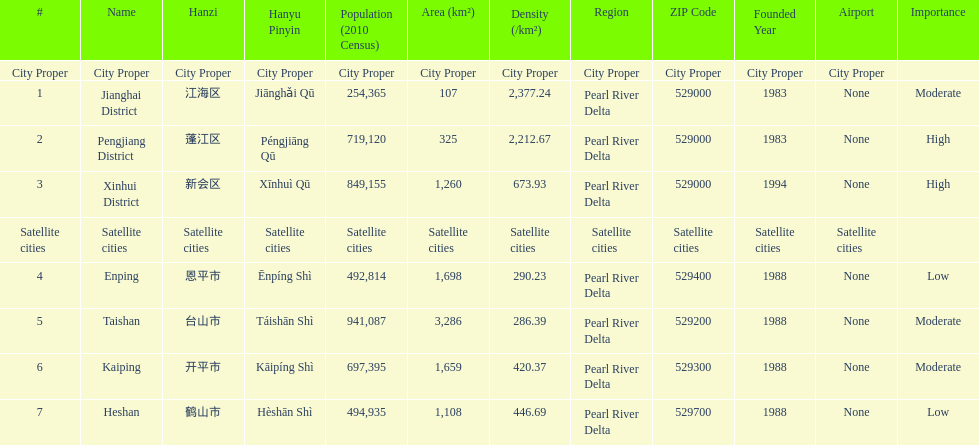What cities are there in jiangmen? Jianghai District, Pengjiang District, Xinhui District, Enping, Taishan, Kaiping, Heshan. Of those, which ones are a city proper? Jianghai District, Pengjiang District, Xinhui District. Of those, which one has the smallest area in km2? Jianghai District. 